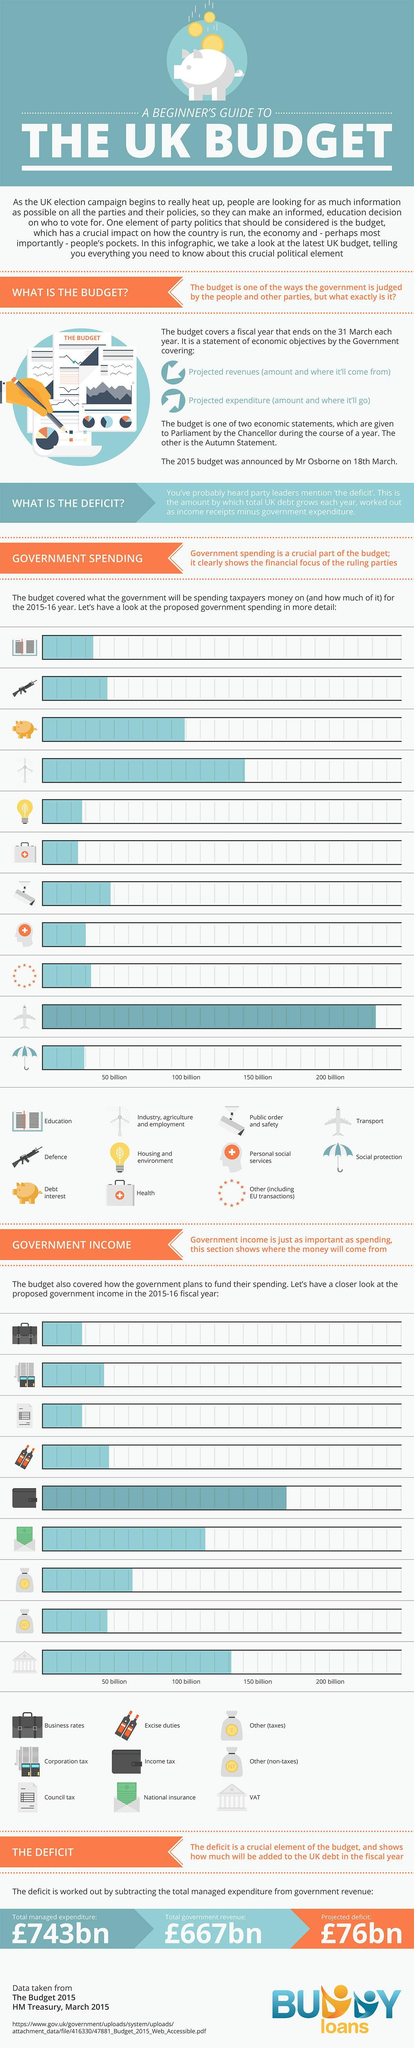The symbol gun represents which branch?
Answer the question with a short phrase. Defence In how many areas the government's income is more than 200 billion? 0 In how many areas the government's income is less than 50 billion? 2 In which area government's income is the second-highest? VAT In how many areas the government spends less than 50 billion? 6 In which area the government spends more than 200 billion? Transport In how many areas the government's income is more than 150 billion? Income tax 